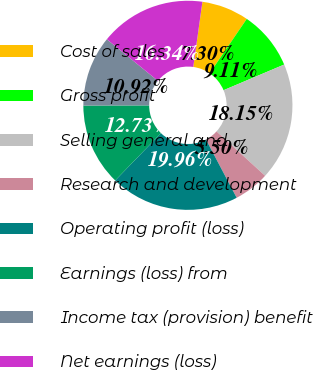<chart> <loc_0><loc_0><loc_500><loc_500><pie_chart><fcel>Cost of sales<fcel>Gross profit<fcel>Selling general and<fcel>Research and development<fcel>Operating profit (loss)<fcel>Earnings (loss) from<fcel>Income tax (provision) benefit<fcel>Net earnings (loss)<nl><fcel>7.3%<fcel>9.11%<fcel>18.15%<fcel>5.5%<fcel>19.96%<fcel>12.73%<fcel>10.92%<fcel>16.34%<nl></chart> 